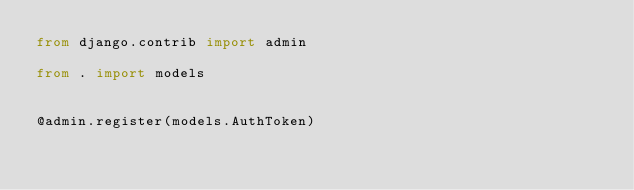<code> <loc_0><loc_0><loc_500><loc_500><_Python_>from django.contrib import admin

from . import models


@admin.register(models.AuthToken)</code> 